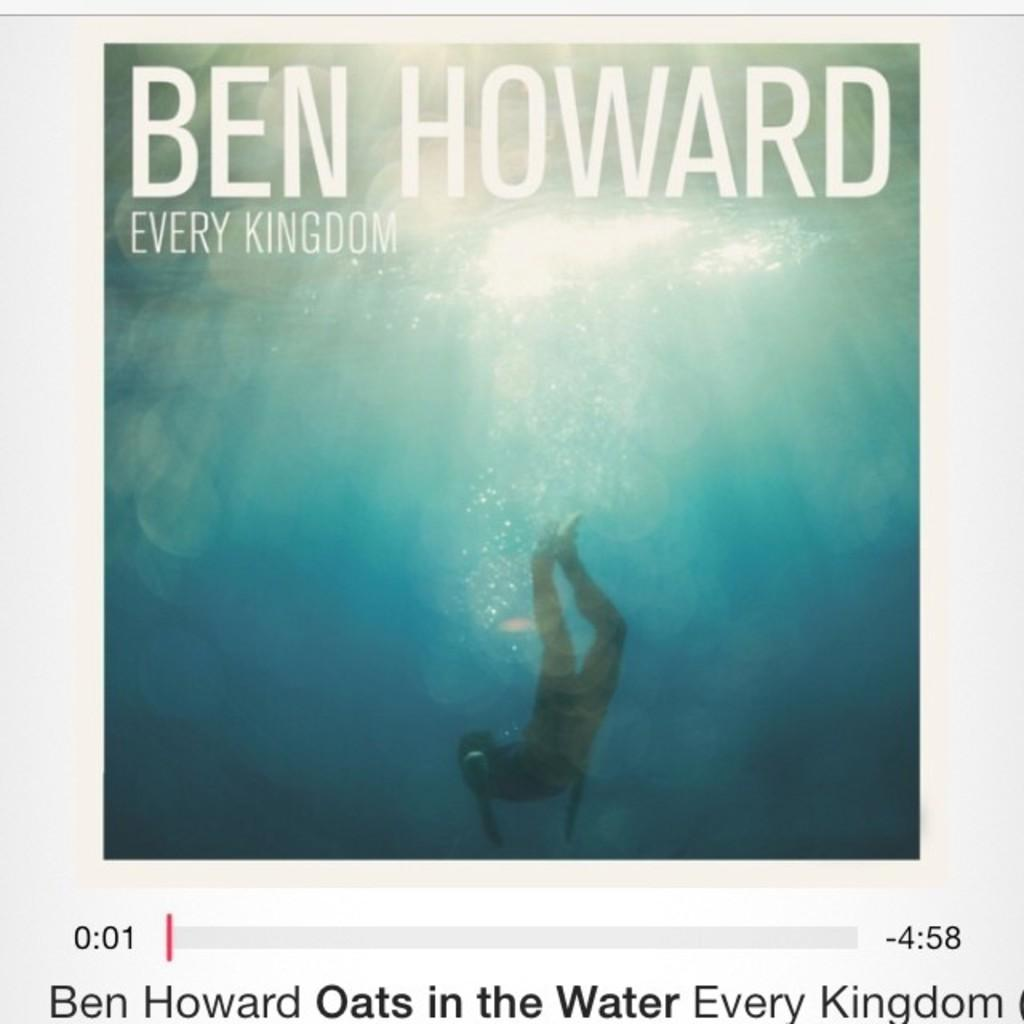<image>
Write a terse but informative summary of the picture. The cover for "Every Kingdom" by Ben Howard features an underwater photograph. 